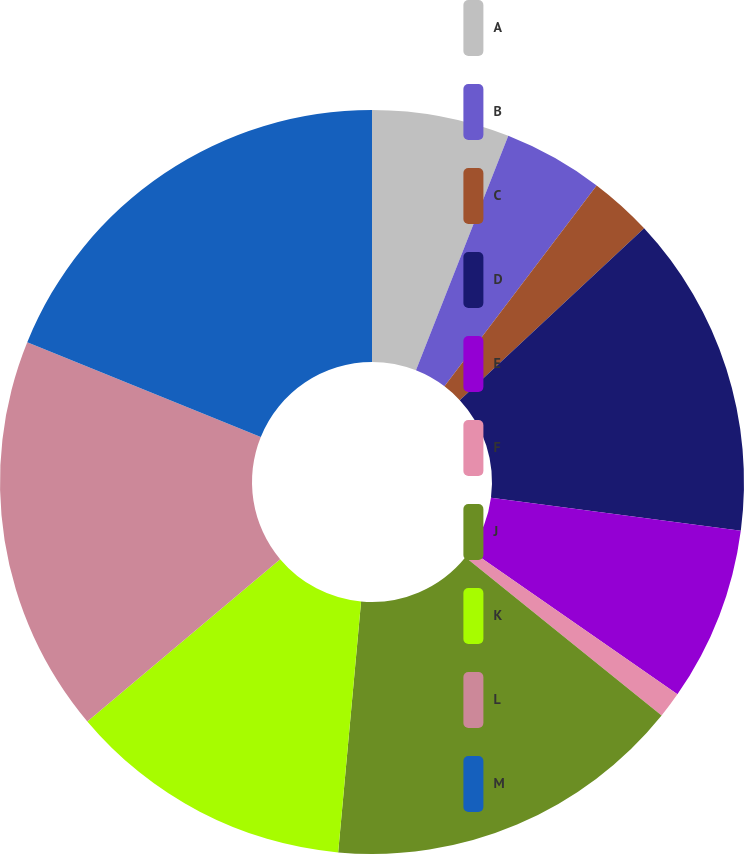Convert chart. <chart><loc_0><loc_0><loc_500><loc_500><pie_chart><fcel>A<fcel>B<fcel>C<fcel>D<fcel>E<fcel>F<fcel>J<fcel>K<fcel>L<fcel>M<nl><fcel>5.97%<fcel>4.35%<fcel>2.74%<fcel>14.03%<fcel>7.58%<fcel>1.13%<fcel>15.65%<fcel>12.42%<fcel>17.26%<fcel>18.87%<nl></chart> 